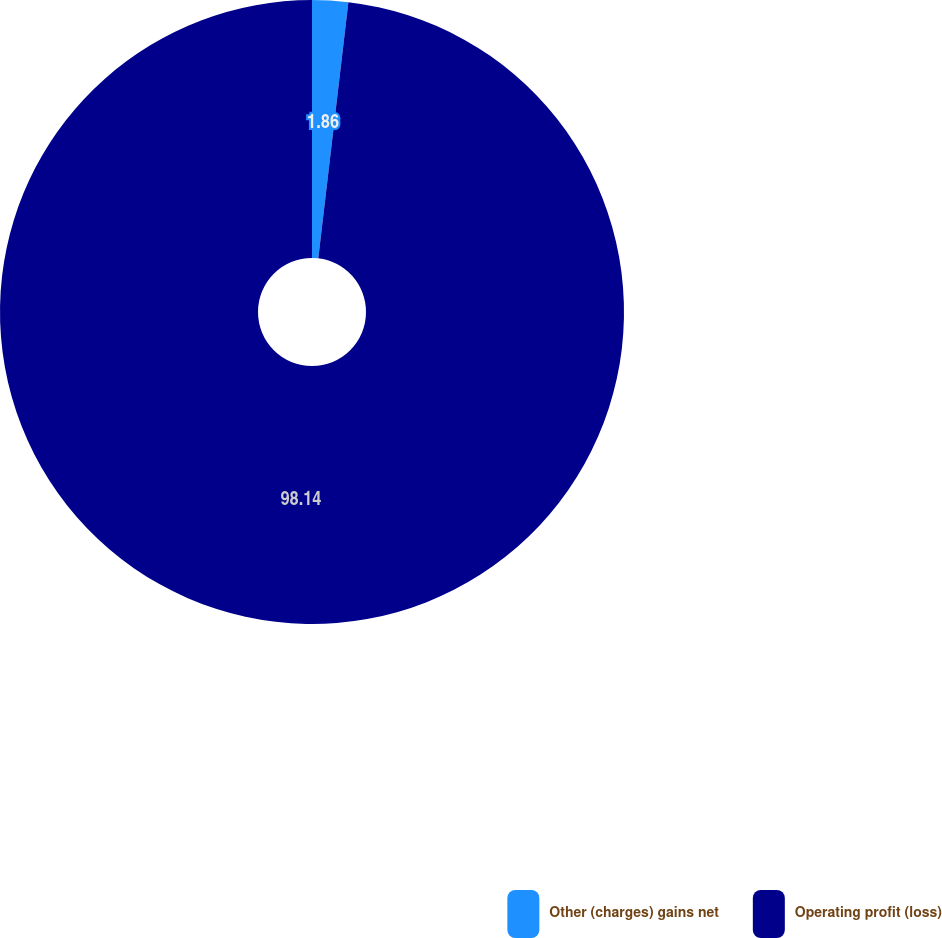Convert chart. <chart><loc_0><loc_0><loc_500><loc_500><pie_chart><fcel>Other (charges) gains net<fcel>Operating profit (loss)<nl><fcel>1.86%<fcel>98.14%<nl></chart> 